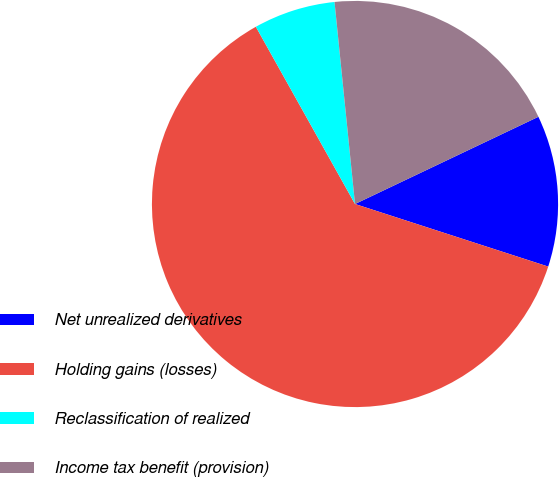Convert chart to OTSL. <chart><loc_0><loc_0><loc_500><loc_500><pie_chart><fcel>Net unrealized derivatives<fcel>Holding gains (losses)<fcel>Reclassification of realized<fcel>Income tax benefit (provision)<nl><fcel>12.05%<fcel>61.89%<fcel>6.51%<fcel>19.54%<nl></chart> 